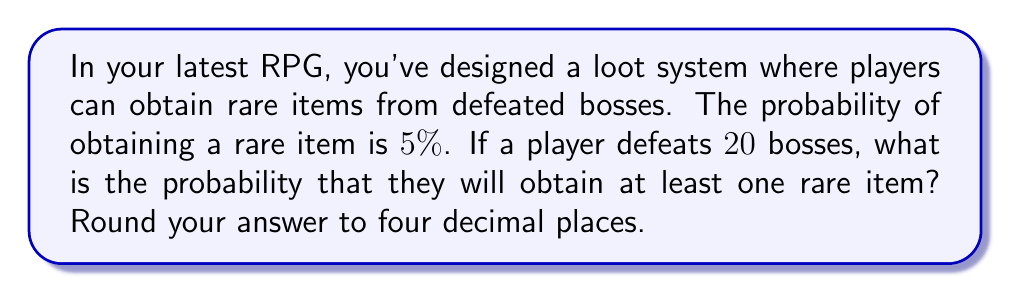What is the answer to this math problem? Let's approach this step-by-step:

1) First, we need to understand that this is a binomial probability problem. We're looking for the probability of at least one success in a series of independent trials.

2) It's often easier to calculate the probability of the complement event (getting no rare items) and then subtract that from 1.

3) The probability of not getting a rare item on a single boss defeat is:
   $1 - 0.05 = 0.95$ or 95%

4) For 20 independent boss defeats, the probability of getting no rare items is:
   $0.95^{20}$

5) Therefore, the probability of getting at least one rare item is:
   $1 - 0.95^{20}$

6) Let's calculate this:
   $$\begin{align}
   P(\text{at least one rare item}) &= 1 - 0.95^{20} \\
   &= 1 - 0.3585840200409022 \\
   &= 0.6414159799590978
   \end{align}$$

7) Rounding to four decimal places:
   $0.6414159799590978 \approx 0.6414$

This means there's about a 64.14% chance of getting at least one rare item after defeating 20 bosses.
Answer: 0.6414 